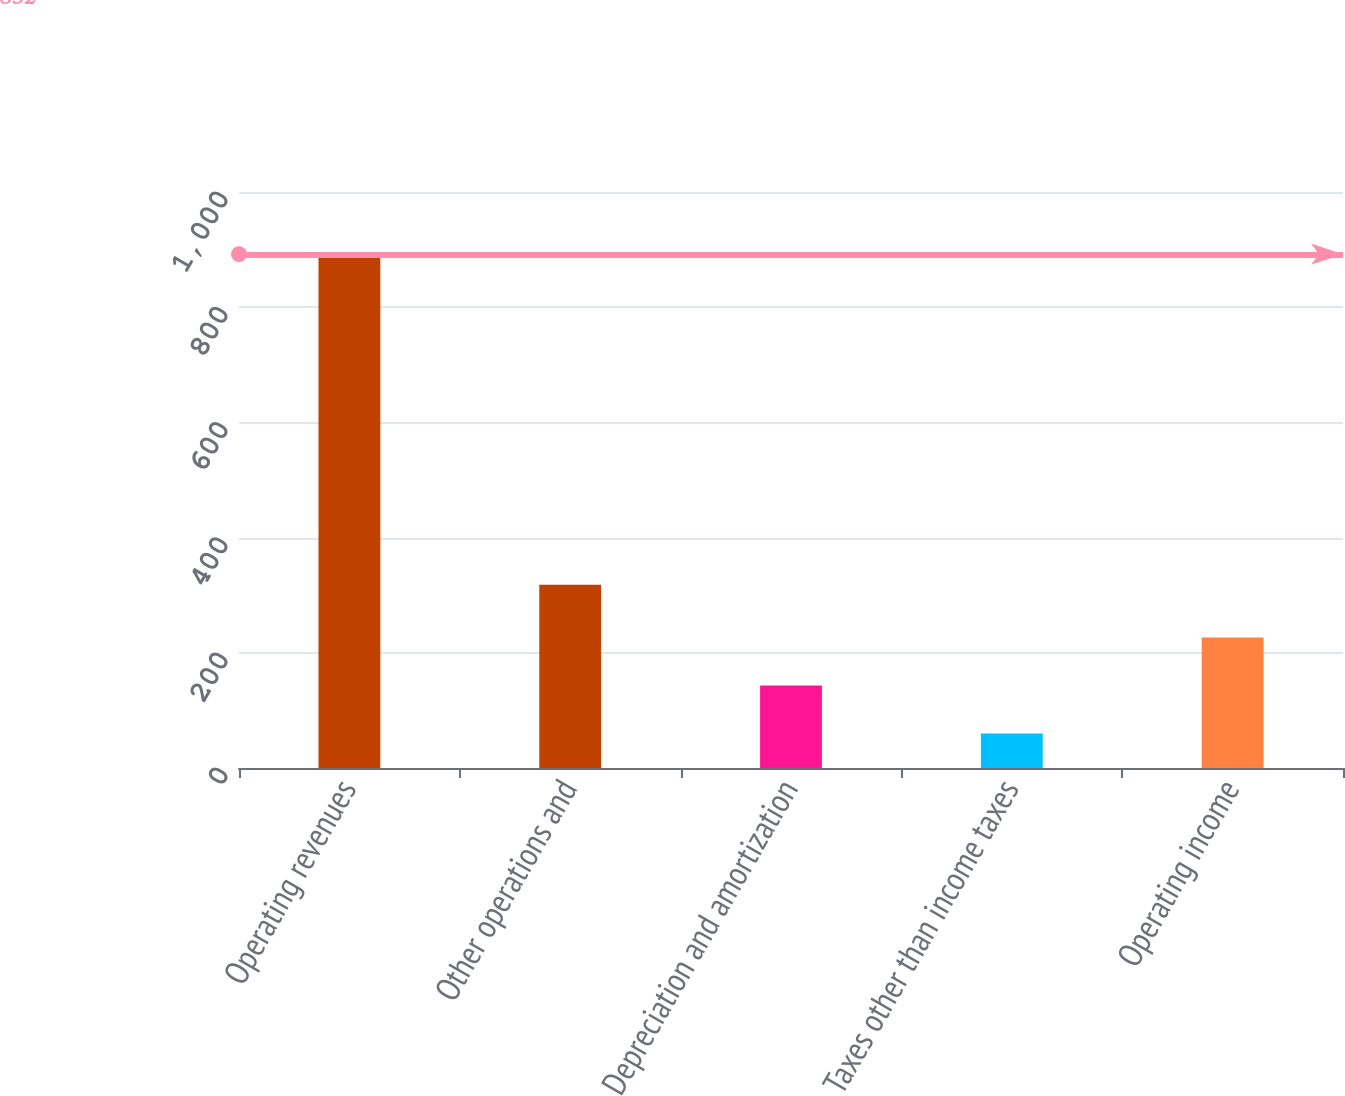<chart> <loc_0><loc_0><loc_500><loc_500><bar_chart><fcel>Operating revenues<fcel>Other operations and<fcel>Depreciation and amortization<fcel>Taxes other than income taxes<fcel>Operating income<nl><fcel>892<fcel>318<fcel>143.2<fcel>60<fcel>226.4<nl></chart> 